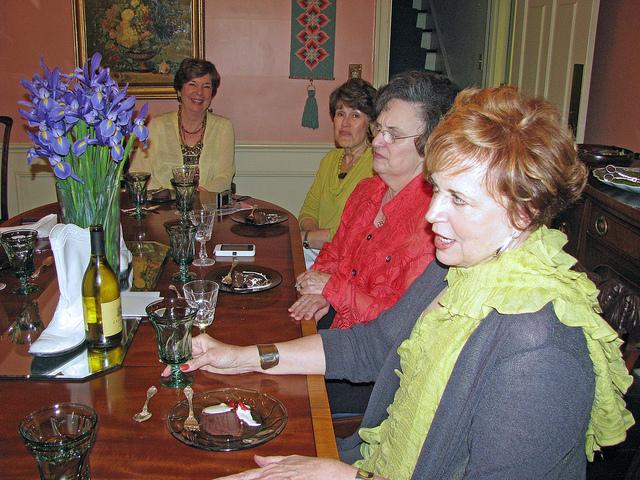What color are the flowers?
Write a very short answer. Blue. Are the people sitting or standing?
Short answer required. Sitting. What occasion does this appear to be?
Be succinct. Dinner. How many people are there?
Concise answer only. 4. 